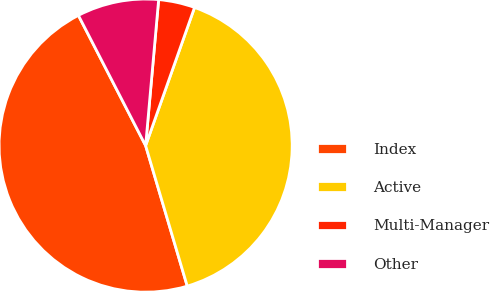Convert chart. <chart><loc_0><loc_0><loc_500><loc_500><pie_chart><fcel>Index<fcel>Active<fcel>Multi-Manager<fcel>Other<nl><fcel>47.0%<fcel>40.0%<fcel>4.0%<fcel>9.0%<nl></chart> 